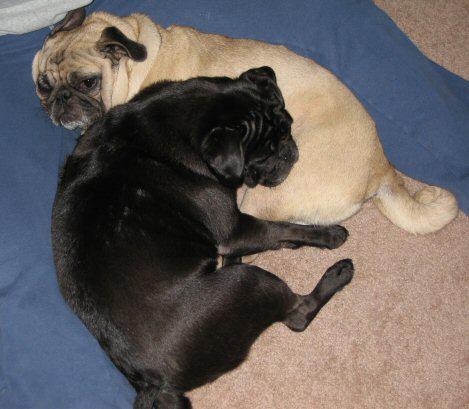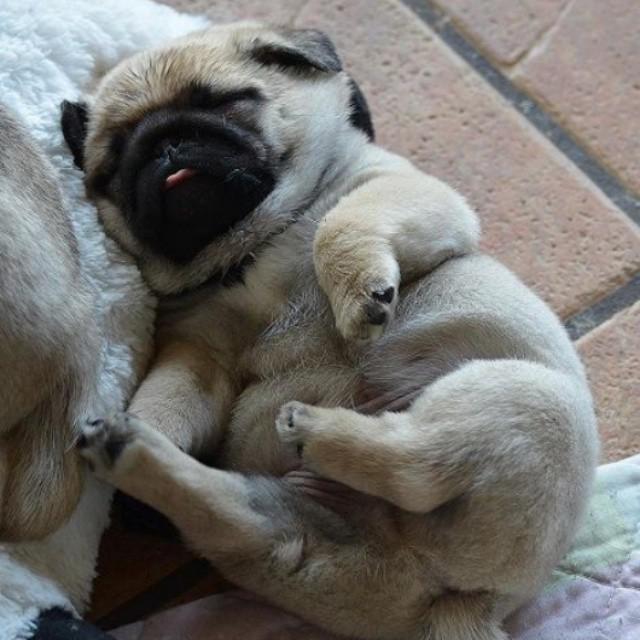The first image is the image on the left, the second image is the image on the right. Given the left and right images, does the statement "At least one of the images shows a dog with a visible tongue outside of it's mouth." hold true? Answer yes or no. Yes. 